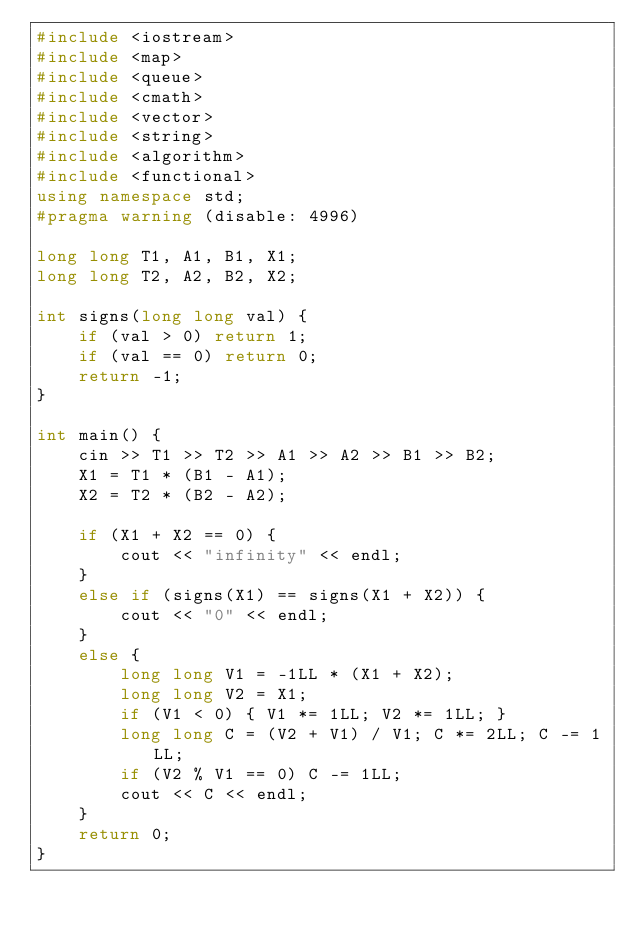Convert code to text. <code><loc_0><loc_0><loc_500><loc_500><_C++_>#include <iostream>
#include <map>
#include <queue>
#include <cmath>
#include <vector>
#include <string>
#include <algorithm>
#include <functional>
using namespace std;
#pragma warning (disable: 4996)

long long T1, A1, B1, X1;
long long T2, A2, B2, X2;

int signs(long long val) {
	if (val > 0) return 1;
	if (val == 0) return 0;
	return -1;
}

int main() {
	cin >> T1 >> T2 >> A1 >> A2 >> B1 >> B2;
	X1 = T1 * (B1 - A1);
	X2 = T2 * (B2 - A2);

	if (X1 + X2 == 0) {
		cout << "infinity" << endl;
	}
	else if (signs(X1) == signs(X1 + X2)) {
		cout << "0" << endl;
	}
	else {
		long long V1 = -1LL * (X1 + X2);
		long long V2 = X1;
		if (V1 < 0) { V1 *= 1LL; V2 *= 1LL; }
		long long C = (V2 + V1) / V1; C *= 2LL; C -= 1LL;
		if (V2 % V1 == 0) C -= 1LL;
		cout << C << endl;
	}
	return 0;
}</code> 